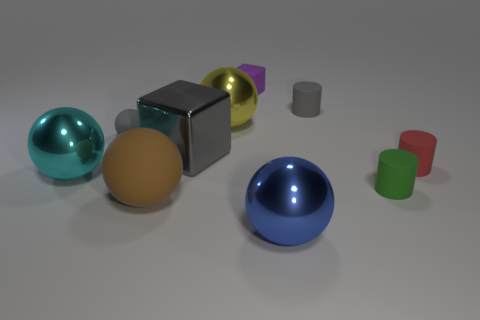What material is the object that is both on the left side of the purple thing and in front of the tiny green matte object?
Offer a terse response. Rubber. There is a gray metal cube; what number of gray blocks are on the right side of it?
Offer a very short reply. 0. Are there any other things that are the same size as the yellow ball?
Keep it short and to the point. Yes. There is a tiny ball that is the same material as the tiny purple cube; what is its color?
Give a very brief answer. Gray. Is the shape of the small purple object the same as the tiny red matte object?
Offer a very short reply. No. How many rubber things are both behind the tiny red object and to the left of the large blue object?
Offer a very short reply. 2. How many matte objects are brown cylinders or cyan balls?
Your answer should be compact. 0. There is a rubber sphere that is behind the cube in front of the yellow ball; how big is it?
Offer a terse response. Small. There is a cylinder that is the same color as the big metallic cube; what is it made of?
Ensure brevity in your answer.  Rubber. There is a gray rubber thing in front of the big ball behind the cyan object; is there a tiny purple matte block on the left side of it?
Offer a very short reply. No. 